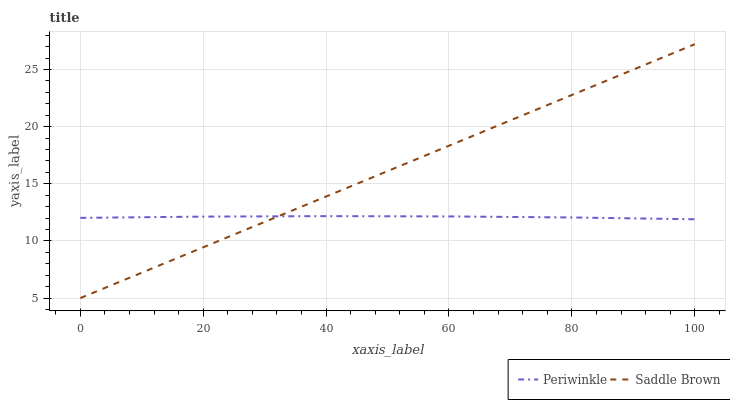Does Periwinkle have the minimum area under the curve?
Answer yes or no. Yes. Does Saddle Brown have the maximum area under the curve?
Answer yes or no. Yes. Does Saddle Brown have the minimum area under the curve?
Answer yes or no. No. Is Saddle Brown the smoothest?
Answer yes or no. Yes. Is Periwinkle the roughest?
Answer yes or no. Yes. Is Saddle Brown the roughest?
Answer yes or no. No. Does Saddle Brown have the lowest value?
Answer yes or no. Yes. Does Saddle Brown have the highest value?
Answer yes or no. Yes. Does Periwinkle intersect Saddle Brown?
Answer yes or no. Yes. Is Periwinkle less than Saddle Brown?
Answer yes or no. No. Is Periwinkle greater than Saddle Brown?
Answer yes or no. No. 